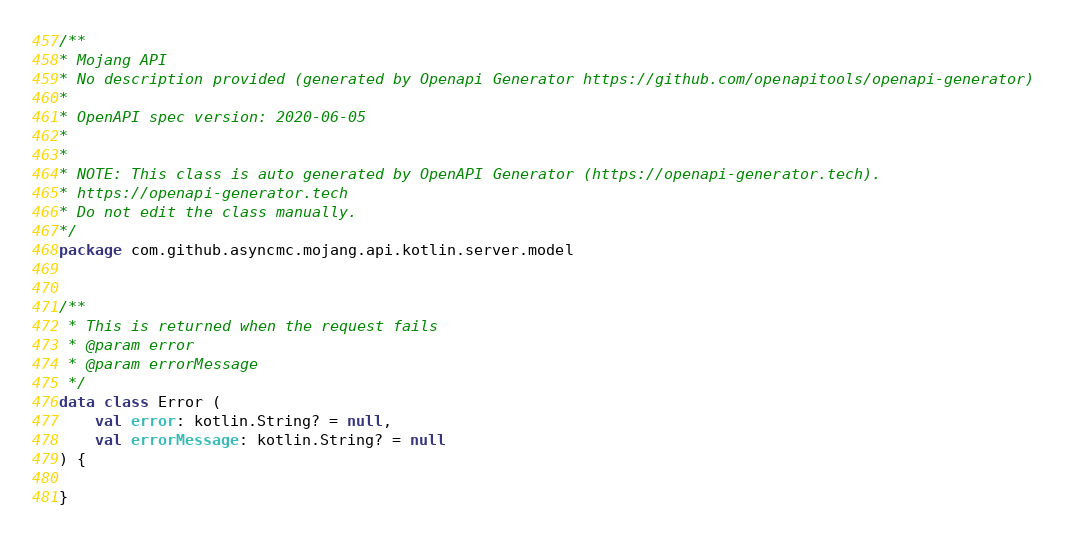<code> <loc_0><loc_0><loc_500><loc_500><_Kotlin_>/**
* Mojang API
* No description provided (generated by Openapi Generator https://github.com/openapitools/openapi-generator)
*
* OpenAPI spec version: 2020-06-05
* 
*
* NOTE: This class is auto generated by OpenAPI Generator (https://openapi-generator.tech).
* https://openapi-generator.tech
* Do not edit the class manually.
*/
package com.github.asyncmc.mojang.api.kotlin.server.model


/**
 * This is returned when the request fails
 * @param error 
 * @param errorMessage 
 */
data class Error (
    val error: kotlin.String? = null,
    val errorMessage: kotlin.String? = null
) {

}

</code> 